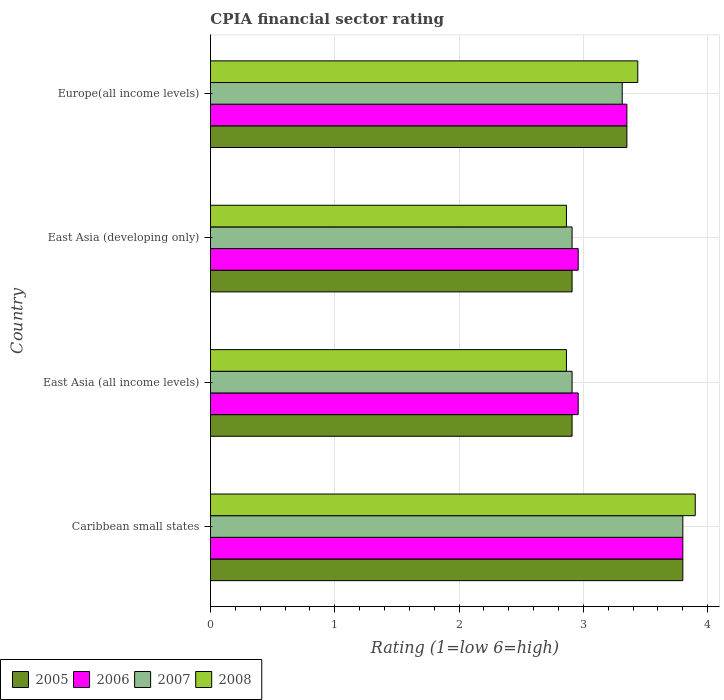How many groups of bars are there?
Keep it short and to the point. 4. Are the number of bars on each tick of the Y-axis equal?
Provide a succinct answer. Yes. How many bars are there on the 4th tick from the top?
Offer a very short reply. 4. What is the label of the 2nd group of bars from the top?
Offer a terse response. East Asia (developing only). What is the CPIA rating in 2006 in East Asia (all income levels)?
Your answer should be compact. 2.96. Across all countries, what is the minimum CPIA rating in 2008?
Keep it short and to the point. 2.86. In which country was the CPIA rating in 2006 maximum?
Keep it short and to the point. Caribbean small states. In which country was the CPIA rating in 2006 minimum?
Your answer should be compact. East Asia (all income levels). What is the total CPIA rating in 2007 in the graph?
Keep it short and to the point. 12.93. What is the difference between the CPIA rating in 2008 in East Asia (all income levels) and that in Europe(all income levels)?
Give a very brief answer. -0.57. What is the difference between the CPIA rating in 2005 in Caribbean small states and the CPIA rating in 2006 in East Asia (developing only)?
Ensure brevity in your answer.  0.84. What is the average CPIA rating in 2006 per country?
Keep it short and to the point. 3.27. What is the difference between the CPIA rating in 2008 and CPIA rating in 2005 in East Asia (all income levels)?
Give a very brief answer. -0.05. What is the ratio of the CPIA rating in 2008 in Caribbean small states to that in East Asia (developing only)?
Provide a succinct answer. 1.36. Is the difference between the CPIA rating in 2008 in East Asia (developing only) and Europe(all income levels) greater than the difference between the CPIA rating in 2005 in East Asia (developing only) and Europe(all income levels)?
Offer a terse response. No. What is the difference between the highest and the second highest CPIA rating in 2005?
Make the answer very short. 0.45. What is the difference between the highest and the lowest CPIA rating in 2005?
Give a very brief answer. 0.89. Is it the case that in every country, the sum of the CPIA rating in 2007 and CPIA rating in 2006 is greater than the sum of CPIA rating in 2005 and CPIA rating in 2008?
Keep it short and to the point. No. What does the 3rd bar from the top in Europe(all income levels) represents?
Your answer should be very brief. 2006. What does the 3rd bar from the bottom in Caribbean small states represents?
Make the answer very short. 2007. Is it the case that in every country, the sum of the CPIA rating in 2008 and CPIA rating in 2006 is greater than the CPIA rating in 2007?
Give a very brief answer. Yes. What is the difference between two consecutive major ticks on the X-axis?
Provide a succinct answer. 1. Are the values on the major ticks of X-axis written in scientific E-notation?
Your answer should be very brief. No. Does the graph contain any zero values?
Give a very brief answer. No. Does the graph contain grids?
Ensure brevity in your answer.  Yes. How many legend labels are there?
Offer a terse response. 4. What is the title of the graph?
Offer a very short reply. CPIA financial sector rating. Does "1987" appear as one of the legend labels in the graph?
Your response must be concise. No. What is the label or title of the Y-axis?
Give a very brief answer. Country. What is the Rating (1=low 6=high) in 2006 in Caribbean small states?
Offer a very short reply. 3.8. What is the Rating (1=low 6=high) of 2005 in East Asia (all income levels)?
Provide a succinct answer. 2.91. What is the Rating (1=low 6=high) of 2006 in East Asia (all income levels)?
Your answer should be very brief. 2.96. What is the Rating (1=low 6=high) in 2007 in East Asia (all income levels)?
Keep it short and to the point. 2.91. What is the Rating (1=low 6=high) in 2008 in East Asia (all income levels)?
Ensure brevity in your answer.  2.86. What is the Rating (1=low 6=high) in 2005 in East Asia (developing only)?
Your answer should be compact. 2.91. What is the Rating (1=low 6=high) of 2006 in East Asia (developing only)?
Ensure brevity in your answer.  2.96. What is the Rating (1=low 6=high) in 2007 in East Asia (developing only)?
Make the answer very short. 2.91. What is the Rating (1=low 6=high) of 2008 in East Asia (developing only)?
Offer a very short reply. 2.86. What is the Rating (1=low 6=high) in 2005 in Europe(all income levels)?
Provide a short and direct response. 3.35. What is the Rating (1=low 6=high) of 2006 in Europe(all income levels)?
Provide a succinct answer. 3.35. What is the Rating (1=low 6=high) in 2007 in Europe(all income levels)?
Your answer should be compact. 3.31. What is the Rating (1=low 6=high) of 2008 in Europe(all income levels)?
Your response must be concise. 3.44. Across all countries, what is the maximum Rating (1=low 6=high) in 2006?
Ensure brevity in your answer.  3.8. Across all countries, what is the minimum Rating (1=low 6=high) in 2005?
Your answer should be very brief. 2.91. Across all countries, what is the minimum Rating (1=low 6=high) of 2006?
Ensure brevity in your answer.  2.96. Across all countries, what is the minimum Rating (1=low 6=high) in 2007?
Your response must be concise. 2.91. Across all countries, what is the minimum Rating (1=low 6=high) of 2008?
Provide a short and direct response. 2.86. What is the total Rating (1=low 6=high) of 2005 in the graph?
Ensure brevity in your answer.  12.97. What is the total Rating (1=low 6=high) in 2006 in the graph?
Provide a short and direct response. 13.07. What is the total Rating (1=low 6=high) of 2007 in the graph?
Keep it short and to the point. 12.93. What is the total Rating (1=low 6=high) of 2008 in the graph?
Make the answer very short. 13.06. What is the difference between the Rating (1=low 6=high) in 2005 in Caribbean small states and that in East Asia (all income levels)?
Make the answer very short. 0.89. What is the difference between the Rating (1=low 6=high) in 2006 in Caribbean small states and that in East Asia (all income levels)?
Ensure brevity in your answer.  0.84. What is the difference between the Rating (1=low 6=high) of 2007 in Caribbean small states and that in East Asia (all income levels)?
Your response must be concise. 0.89. What is the difference between the Rating (1=low 6=high) of 2008 in Caribbean small states and that in East Asia (all income levels)?
Offer a very short reply. 1.04. What is the difference between the Rating (1=low 6=high) of 2005 in Caribbean small states and that in East Asia (developing only)?
Your answer should be compact. 0.89. What is the difference between the Rating (1=low 6=high) in 2006 in Caribbean small states and that in East Asia (developing only)?
Provide a short and direct response. 0.84. What is the difference between the Rating (1=low 6=high) in 2007 in Caribbean small states and that in East Asia (developing only)?
Offer a terse response. 0.89. What is the difference between the Rating (1=low 6=high) of 2008 in Caribbean small states and that in East Asia (developing only)?
Make the answer very short. 1.04. What is the difference between the Rating (1=low 6=high) in 2005 in Caribbean small states and that in Europe(all income levels)?
Give a very brief answer. 0.45. What is the difference between the Rating (1=low 6=high) in 2006 in Caribbean small states and that in Europe(all income levels)?
Provide a succinct answer. 0.45. What is the difference between the Rating (1=low 6=high) in 2007 in Caribbean small states and that in Europe(all income levels)?
Your response must be concise. 0.49. What is the difference between the Rating (1=low 6=high) of 2008 in Caribbean small states and that in Europe(all income levels)?
Give a very brief answer. 0.46. What is the difference between the Rating (1=low 6=high) in 2005 in East Asia (all income levels) and that in East Asia (developing only)?
Provide a succinct answer. 0. What is the difference between the Rating (1=low 6=high) of 2006 in East Asia (all income levels) and that in East Asia (developing only)?
Your answer should be very brief. 0. What is the difference between the Rating (1=low 6=high) of 2007 in East Asia (all income levels) and that in East Asia (developing only)?
Ensure brevity in your answer.  0. What is the difference between the Rating (1=low 6=high) in 2005 in East Asia (all income levels) and that in Europe(all income levels)?
Your response must be concise. -0.44. What is the difference between the Rating (1=low 6=high) of 2006 in East Asia (all income levels) and that in Europe(all income levels)?
Give a very brief answer. -0.39. What is the difference between the Rating (1=low 6=high) of 2007 in East Asia (all income levels) and that in Europe(all income levels)?
Provide a succinct answer. -0.4. What is the difference between the Rating (1=low 6=high) of 2008 in East Asia (all income levels) and that in Europe(all income levels)?
Provide a succinct answer. -0.57. What is the difference between the Rating (1=low 6=high) in 2005 in East Asia (developing only) and that in Europe(all income levels)?
Provide a succinct answer. -0.44. What is the difference between the Rating (1=low 6=high) of 2006 in East Asia (developing only) and that in Europe(all income levels)?
Ensure brevity in your answer.  -0.39. What is the difference between the Rating (1=low 6=high) of 2007 in East Asia (developing only) and that in Europe(all income levels)?
Provide a short and direct response. -0.4. What is the difference between the Rating (1=low 6=high) of 2008 in East Asia (developing only) and that in Europe(all income levels)?
Your answer should be compact. -0.57. What is the difference between the Rating (1=low 6=high) in 2005 in Caribbean small states and the Rating (1=low 6=high) in 2006 in East Asia (all income levels)?
Provide a succinct answer. 0.84. What is the difference between the Rating (1=low 6=high) of 2005 in Caribbean small states and the Rating (1=low 6=high) of 2007 in East Asia (all income levels)?
Ensure brevity in your answer.  0.89. What is the difference between the Rating (1=low 6=high) of 2005 in Caribbean small states and the Rating (1=low 6=high) of 2008 in East Asia (all income levels)?
Your answer should be compact. 0.94. What is the difference between the Rating (1=low 6=high) in 2006 in Caribbean small states and the Rating (1=low 6=high) in 2007 in East Asia (all income levels)?
Your answer should be very brief. 0.89. What is the difference between the Rating (1=low 6=high) of 2006 in Caribbean small states and the Rating (1=low 6=high) of 2008 in East Asia (all income levels)?
Keep it short and to the point. 0.94. What is the difference between the Rating (1=low 6=high) in 2007 in Caribbean small states and the Rating (1=low 6=high) in 2008 in East Asia (all income levels)?
Provide a short and direct response. 0.94. What is the difference between the Rating (1=low 6=high) of 2005 in Caribbean small states and the Rating (1=low 6=high) of 2006 in East Asia (developing only)?
Keep it short and to the point. 0.84. What is the difference between the Rating (1=low 6=high) of 2005 in Caribbean small states and the Rating (1=low 6=high) of 2007 in East Asia (developing only)?
Provide a succinct answer. 0.89. What is the difference between the Rating (1=low 6=high) in 2005 in Caribbean small states and the Rating (1=low 6=high) in 2008 in East Asia (developing only)?
Offer a very short reply. 0.94. What is the difference between the Rating (1=low 6=high) of 2006 in Caribbean small states and the Rating (1=low 6=high) of 2007 in East Asia (developing only)?
Provide a succinct answer. 0.89. What is the difference between the Rating (1=low 6=high) in 2006 in Caribbean small states and the Rating (1=low 6=high) in 2008 in East Asia (developing only)?
Make the answer very short. 0.94. What is the difference between the Rating (1=low 6=high) in 2007 in Caribbean small states and the Rating (1=low 6=high) in 2008 in East Asia (developing only)?
Make the answer very short. 0.94. What is the difference between the Rating (1=low 6=high) in 2005 in Caribbean small states and the Rating (1=low 6=high) in 2006 in Europe(all income levels)?
Give a very brief answer. 0.45. What is the difference between the Rating (1=low 6=high) in 2005 in Caribbean small states and the Rating (1=low 6=high) in 2007 in Europe(all income levels)?
Keep it short and to the point. 0.49. What is the difference between the Rating (1=low 6=high) of 2005 in Caribbean small states and the Rating (1=low 6=high) of 2008 in Europe(all income levels)?
Make the answer very short. 0.36. What is the difference between the Rating (1=low 6=high) in 2006 in Caribbean small states and the Rating (1=low 6=high) in 2007 in Europe(all income levels)?
Provide a short and direct response. 0.49. What is the difference between the Rating (1=low 6=high) of 2006 in Caribbean small states and the Rating (1=low 6=high) of 2008 in Europe(all income levels)?
Ensure brevity in your answer.  0.36. What is the difference between the Rating (1=low 6=high) in 2007 in Caribbean small states and the Rating (1=low 6=high) in 2008 in Europe(all income levels)?
Your answer should be very brief. 0.36. What is the difference between the Rating (1=low 6=high) in 2005 in East Asia (all income levels) and the Rating (1=low 6=high) in 2006 in East Asia (developing only)?
Provide a succinct answer. -0.05. What is the difference between the Rating (1=low 6=high) in 2005 in East Asia (all income levels) and the Rating (1=low 6=high) in 2008 in East Asia (developing only)?
Offer a very short reply. 0.05. What is the difference between the Rating (1=low 6=high) of 2006 in East Asia (all income levels) and the Rating (1=low 6=high) of 2007 in East Asia (developing only)?
Your response must be concise. 0.05. What is the difference between the Rating (1=low 6=high) of 2006 in East Asia (all income levels) and the Rating (1=low 6=high) of 2008 in East Asia (developing only)?
Make the answer very short. 0.09. What is the difference between the Rating (1=low 6=high) of 2007 in East Asia (all income levels) and the Rating (1=low 6=high) of 2008 in East Asia (developing only)?
Your answer should be very brief. 0.05. What is the difference between the Rating (1=low 6=high) in 2005 in East Asia (all income levels) and the Rating (1=low 6=high) in 2006 in Europe(all income levels)?
Ensure brevity in your answer.  -0.44. What is the difference between the Rating (1=low 6=high) in 2005 in East Asia (all income levels) and the Rating (1=low 6=high) in 2007 in Europe(all income levels)?
Give a very brief answer. -0.4. What is the difference between the Rating (1=low 6=high) in 2005 in East Asia (all income levels) and the Rating (1=low 6=high) in 2008 in Europe(all income levels)?
Keep it short and to the point. -0.53. What is the difference between the Rating (1=low 6=high) in 2006 in East Asia (all income levels) and the Rating (1=low 6=high) in 2007 in Europe(all income levels)?
Offer a very short reply. -0.35. What is the difference between the Rating (1=low 6=high) in 2006 in East Asia (all income levels) and the Rating (1=low 6=high) in 2008 in Europe(all income levels)?
Your answer should be very brief. -0.48. What is the difference between the Rating (1=low 6=high) of 2007 in East Asia (all income levels) and the Rating (1=low 6=high) of 2008 in Europe(all income levels)?
Offer a terse response. -0.53. What is the difference between the Rating (1=low 6=high) of 2005 in East Asia (developing only) and the Rating (1=low 6=high) of 2006 in Europe(all income levels)?
Keep it short and to the point. -0.44. What is the difference between the Rating (1=low 6=high) of 2005 in East Asia (developing only) and the Rating (1=low 6=high) of 2007 in Europe(all income levels)?
Your answer should be compact. -0.4. What is the difference between the Rating (1=low 6=high) of 2005 in East Asia (developing only) and the Rating (1=low 6=high) of 2008 in Europe(all income levels)?
Your answer should be compact. -0.53. What is the difference between the Rating (1=low 6=high) of 2006 in East Asia (developing only) and the Rating (1=low 6=high) of 2007 in Europe(all income levels)?
Your answer should be very brief. -0.35. What is the difference between the Rating (1=low 6=high) in 2006 in East Asia (developing only) and the Rating (1=low 6=high) in 2008 in Europe(all income levels)?
Your response must be concise. -0.48. What is the difference between the Rating (1=low 6=high) of 2007 in East Asia (developing only) and the Rating (1=low 6=high) of 2008 in Europe(all income levels)?
Provide a succinct answer. -0.53. What is the average Rating (1=low 6=high) in 2005 per country?
Your answer should be compact. 3.24. What is the average Rating (1=low 6=high) in 2006 per country?
Your answer should be compact. 3.27. What is the average Rating (1=low 6=high) in 2007 per country?
Give a very brief answer. 3.23. What is the average Rating (1=low 6=high) of 2008 per country?
Keep it short and to the point. 3.27. What is the difference between the Rating (1=low 6=high) in 2005 and Rating (1=low 6=high) in 2008 in Caribbean small states?
Your answer should be compact. -0.1. What is the difference between the Rating (1=low 6=high) in 2005 and Rating (1=low 6=high) in 2006 in East Asia (all income levels)?
Ensure brevity in your answer.  -0.05. What is the difference between the Rating (1=low 6=high) of 2005 and Rating (1=low 6=high) of 2008 in East Asia (all income levels)?
Your response must be concise. 0.05. What is the difference between the Rating (1=low 6=high) in 2006 and Rating (1=low 6=high) in 2007 in East Asia (all income levels)?
Your answer should be compact. 0.05. What is the difference between the Rating (1=low 6=high) in 2006 and Rating (1=low 6=high) in 2008 in East Asia (all income levels)?
Your response must be concise. 0.09. What is the difference between the Rating (1=low 6=high) of 2007 and Rating (1=low 6=high) of 2008 in East Asia (all income levels)?
Your answer should be compact. 0.05. What is the difference between the Rating (1=low 6=high) in 2005 and Rating (1=low 6=high) in 2006 in East Asia (developing only)?
Give a very brief answer. -0.05. What is the difference between the Rating (1=low 6=high) in 2005 and Rating (1=low 6=high) in 2008 in East Asia (developing only)?
Your response must be concise. 0.05. What is the difference between the Rating (1=low 6=high) of 2006 and Rating (1=low 6=high) of 2007 in East Asia (developing only)?
Your answer should be very brief. 0.05. What is the difference between the Rating (1=low 6=high) of 2006 and Rating (1=low 6=high) of 2008 in East Asia (developing only)?
Keep it short and to the point. 0.09. What is the difference between the Rating (1=low 6=high) of 2007 and Rating (1=low 6=high) of 2008 in East Asia (developing only)?
Your answer should be very brief. 0.05. What is the difference between the Rating (1=low 6=high) in 2005 and Rating (1=low 6=high) in 2006 in Europe(all income levels)?
Keep it short and to the point. 0. What is the difference between the Rating (1=low 6=high) of 2005 and Rating (1=low 6=high) of 2007 in Europe(all income levels)?
Offer a terse response. 0.04. What is the difference between the Rating (1=low 6=high) in 2005 and Rating (1=low 6=high) in 2008 in Europe(all income levels)?
Provide a short and direct response. -0.09. What is the difference between the Rating (1=low 6=high) of 2006 and Rating (1=low 6=high) of 2007 in Europe(all income levels)?
Give a very brief answer. 0.04. What is the difference between the Rating (1=low 6=high) of 2006 and Rating (1=low 6=high) of 2008 in Europe(all income levels)?
Offer a very short reply. -0.09. What is the difference between the Rating (1=low 6=high) in 2007 and Rating (1=low 6=high) in 2008 in Europe(all income levels)?
Your answer should be compact. -0.12. What is the ratio of the Rating (1=low 6=high) of 2005 in Caribbean small states to that in East Asia (all income levels)?
Provide a short and direct response. 1.31. What is the ratio of the Rating (1=low 6=high) of 2006 in Caribbean small states to that in East Asia (all income levels)?
Make the answer very short. 1.28. What is the ratio of the Rating (1=low 6=high) in 2007 in Caribbean small states to that in East Asia (all income levels)?
Make the answer very short. 1.31. What is the ratio of the Rating (1=low 6=high) in 2008 in Caribbean small states to that in East Asia (all income levels)?
Keep it short and to the point. 1.36. What is the ratio of the Rating (1=low 6=high) in 2005 in Caribbean small states to that in East Asia (developing only)?
Offer a terse response. 1.31. What is the ratio of the Rating (1=low 6=high) in 2006 in Caribbean small states to that in East Asia (developing only)?
Make the answer very short. 1.28. What is the ratio of the Rating (1=low 6=high) of 2007 in Caribbean small states to that in East Asia (developing only)?
Provide a short and direct response. 1.31. What is the ratio of the Rating (1=low 6=high) in 2008 in Caribbean small states to that in East Asia (developing only)?
Ensure brevity in your answer.  1.36. What is the ratio of the Rating (1=low 6=high) of 2005 in Caribbean small states to that in Europe(all income levels)?
Make the answer very short. 1.13. What is the ratio of the Rating (1=low 6=high) of 2006 in Caribbean small states to that in Europe(all income levels)?
Make the answer very short. 1.13. What is the ratio of the Rating (1=low 6=high) of 2007 in Caribbean small states to that in Europe(all income levels)?
Offer a very short reply. 1.15. What is the ratio of the Rating (1=low 6=high) of 2008 in Caribbean small states to that in Europe(all income levels)?
Offer a terse response. 1.13. What is the ratio of the Rating (1=low 6=high) in 2008 in East Asia (all income levels) to that in East Asia (developing only)?
Make the answer very short. 1. What is the ratio of the Rating (1=low 6=high) of 2005 in East Asia (all income levels) to that in Europe(all income levels)?
Your answer should be very brief. 0.87. What is the ratio of the Rating (1=low 6=high) of 2006 in East Asia (all income levels) to that in Europe(all income levels)?
Give a very brief answer. 0.88. What is the ratio of the Rating (1=low 6=high) of 2007 in East Asia (all income levels) to that in Europe(all income levels)?
Provide a short and direct response. 0.88. What is the ratio of the Rating (1=low 6=high) in 2008 in East Asia (all income levels) to that in Europe(all income levels)?
Ensure brevity in your answer.  0.83. What is the ratio of the Rating (1=low 6=high) of 2005 in East Asia (developing only) to that in Europe(all income levels)?
Provide a succinct answer. 0.87. What is the ratio of the Rating (1=low 6=high) in 2006 in East Asia (developing only) to that in Europe(all income levels)?
Your answer should be very brief. 0.88. What is the ratio of the Rating (1=low 6=high) of 2007 in East Asia (developing only) to that in Europe(all income levels)?
Your response must be concise. 0.88. What is the ratio of the Rating (1=low 6=high) of 2008 in East Asia (developing only) to that in Europe(all income levels)?
Your response must be concise. 0.83. What is the difference between the highest and the second highest Rating (1=low 6=high) in 2005?
Offer a very short reply. 0.45. What is the difference between the highest and the second highest Rating (1=low 6=high) of 2006?
Give a very brief answer. 0.45. What is the difference between the highest and the second highest Rating (1=low 6=high) of 2007?
Keep it short and to the point. 0.49. What is the difference between the highest and the second highest Rating (1=low 6=high) of 2008?
Your response must be concise. 0.46. What is the difference between the highest and the lowest Rating (1=low 6=high) of 2005?
Your answer should be very brief. 0.89. What is the difference between the highest and the lowest Rating (1=low 6=high) of 2006?
Your response must be concise. 0.84. What is the difference between the highest and the lowest Rating (1=low 6=high) in 2007?
Offer a terse response. 0.89. What is the difference between the highest and the lowest Rating (1=low 6=high) of 2008?
Ensure brevity in your answer.  1.04. 